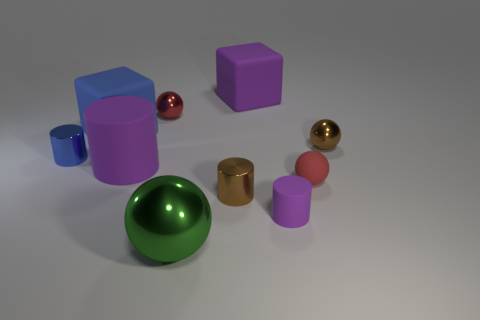Subtract all tiny spheres. How many spheres are left? 1 Subtract all gray cylinders. How many red balls are left? 2 Subtract all red spheres. How many spheres are left? 2 Subtract 1 spheres. How many spheres are left? 3 Subtract all cubes. How many objects are left? 8 Subtract all purple spheres. Subtract all blue cubes. How many spheres are left? 4 Add 8 blue rubber cubes. How many blue rubber cubes exist? 9 Subtract 0 blue spheres. How many objects are left? 10 Subtract all blue matte cylinders. Subtract all tiny red metal objects. How many objects are left? 9 Add 2 big purple cubes. How many big purple cubes are left? 3 